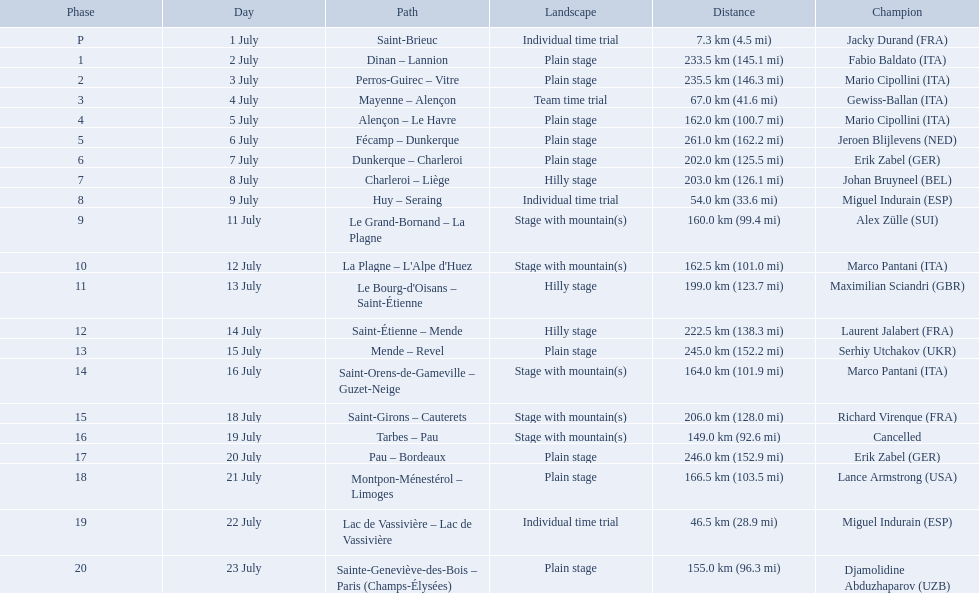What are the dates? 1 July, 2 July, 3 July, 4 July, 5 July, 6 July, 7 July, 8 July, 9 July, 11 July, 12 July, 13 July, 14 July, 15 July, 16 July, 18 July, 19 July, 20 July, 21 July, 22 July, 23 July. What is the length on 8 july? 203.0 km (126.1 mi). What were the lengths of all the stages of the 1995 tour de france? 7.3 km (4.5 mi), 233.5 km (145.1 mi), 235.5 km (146.3 mi), 67.0 km (41.6 mi), 162.0 km (100.7 mi), 261.0 km (162.2 mi), 202.0 km (125.5 mi), 203.0 km (126.1 mi), 54.0 km (33.6 mi), 160.0 km (99.4 mi), 162.5 km (101.0 mi), 199.0 km (123.7 mi), 222.5 km (138.3 mi), 245.0 km (152.2 mi), 164.0 km (101.9 mi), 206.0 km (128.0 mi), 149.0 km (92.6 mi), 246.0 km (152.9 mi), 166.5 km (103.5 mi), 46.5 km (28.9 mi), 155.0 km (96.3 mi). Of those, which one occurred on july 8th? 203.0 km (126.1 mi). 